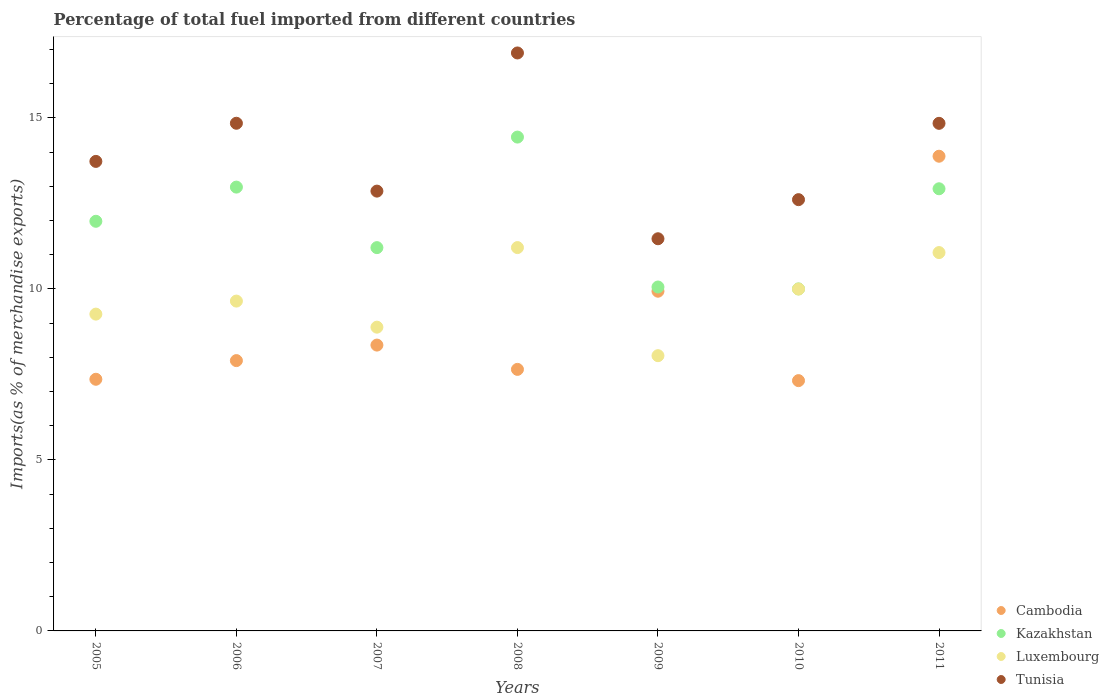Is the number of dotlines equal to the number of legend labels?
Provide a succinct answer. Yes. What is the percentage of imports to different countries in Kazakhstan in 2005?
Your answer should be compact. 11.98. Across all years, what is the maximum percentage of imports to different countries in Kazakhstan?
Offer a very short reply. 14.44. Across all years, what is the minimum percentage of imports to different countries in Cambodia?
Make the answer very short. 7.32. What is the total percentage of imports to different countries in Tunisia in the graph?
Your answer should be compact. 97.25. What is the difference between the percentage of imports to different countries in Cambodia in 2010 and that in 2011?
Provide a short and direct response. -6.56. What is the difference between the percentage of imports to different countries in Cambodia in 2011 and the percentage of imports to different countries in Luxembourg in 2010?
Offer a terse response. 3.88. What is the average percentage of imports to different countries in Luxembourg per year?
Ensure brevity in your answer.  9.73. In the year 2005, what is the difference between the percentage of imports to different countries in Luxembourg and percentage of imports to different countries in Kazakhstan?
Give a very brief answer. -2.71. In how many years, is the percentage of imports to different countries in Tunisia greater than 8 %?
Provide a succinct answer. 7. What is the ratio of the percentage of imports to different countries in Cambodia in 2006 to that in 2008?
Your response must be concise. 1.03. Is the percentage of imports to different countries in Cambodia in 2007 less than that in 2011?
Make the answer very short. Yes. What is the difference between the highest and the second highest percentage of imports to different countries in Kazakhstan?
Provide a short and direct response. 1.46. What is the difference between the highest and the lowest percentage of imports to different countries in Luxembourg?
Provide a succinct answer. 3.16. Is it the case that in every year, the sum of the percentage of imports to different countries in Kazakhstan and percentage of imports to different countries in Luxembourg  is greater than the sum of percentage of imports to different countries in Cambodia and percentage of imports to different countries in Tunisia?
Offer a very short reply. No. Is it the case that in every year, the sum of the percentage of imports to different countries in Tunisia and percentage of imports to different countries in Cambodia  is greater than the percentage of imports to different countries in Kazakhstan?
Keep it short and to the point. Yes. What is the difference between two consecutive major ticks on the Y-axis?
Give a very brief answer. 5. How are the legend labels stacked?
Provide a succinct answer. Vertical. What is the title of the graph?
Keep it short and to the point. Percentage of total fuel imported from different countries. What is the label or title of the Y-axis?
Keep it short and to the point. Imports(as % of merchandise exports). What is the Imports(as % of merchandise exports) of Cambodia in 2005?
Give a very brief answer. 7.36. What is the Imports(as % of merchandise exports) in Kazakhstan in 2005?
Ensure brevity in your answer.  11.98. What is the Imports(as % of merchandise exports) of Luxembourg in 2005?
Your answer should be very brief. 9.26. What is the Imports(as % of merchandise exports) in Tunisia in 2005?
Your response must be concise. 13.73. What is the Imports(as % of merchandise exports) in Cambodia in 2006?
Your answer should be compact. 7.9. What is the Imports(as % of merchandise exports) in Kazakhstan in 2006?
Keep it short and to the point. 12.98. What is the Imports(as % of merchandise exports) in Luxembourg in 2006?
Your answer should be very brief. 9.64. What is the Imports(as % of merchandise exports) in Tunisia in 2006?
Keep it short and to the point. 14.84. What is the Imports(as % of merchandise exports) in Cambodia in 2007?
Offer a terse response. 8.36. What is the Imports(as % of merchandise exports) of Kazakhstan in 2007?
Offer a very short reply. 11.21. What is the Imports(as % of merchandise exports) of Luxembourg in 2007?
Keep it short and to the point. 8.88. What is the Imports(as % of merchandise exports) of Tunisia in 2007?
Provide a succinct answer. 12.86. What is the Imports(as % of merchandise exports) in Cambodia in 2008?
Give a very brief answer. 7.65. What is the Imports(as % of merchandise exports) in Kazakhstan in 2008?
Provide a succinct answer. 14.44. What is the Imports(as % of merchandise exports) of Luxembourg in 2008?
Your answer should be very brief. 11.21. What is the Imports(as % of merchandise exports) in Tunisia in 2008?
Make the answer very short. 16.9. What is the Imports(as % of merchandise exports) of Cambodia in 2009?
Ensure brevity in your answer.  9.93. What is the Imports(as % of merchandise exports) in Kazakhstan in 2009?
Provide a short and direct response. 10.06. What is the Imports(as % of merchandise exports) of Luxembourg in 2009?
Give a very brief answer. 8.05. What is the Imports(as % of merchandise exports) in Tunisia in 2009?
Give a very brief answer. 11.47. What is the Imports(as % of merchandise exports) in Cambodia in 2010?
Make the answer very short. 7.32. What is the Imports(as % of merchandise exports) of Kazakhstan in 2010?
Offer a terse response. 10. What is the Imports(as % of merchandise exports) of Luxembourg in 2010?
Offer a terse response. 10. What is the Imports(as % of merchandise exports) in Tunisia in 2010?
Provide a short and direct response. 12.61. What is the Imports(as % of merchandise exports) in Cambodia in 2011?
Provide a succinct answer. 13.88. What is the Imports(as % of merchandise exports) of Kazakhstan in 2011?
Offer a terse response. 12.93. What is the Imports(as % of merchandise exports) in Luxembourg in 2011?
Offer a terse response. 11.06. What is the Imports(as % of merchandise exports) in Tunisia in 2011?
Ensure brevity in your answer.  14.84. Across all years, what is the maximum Imports(as % of merchandise exports) in Cambodia?
Make the answer very short. 13.88. Across all years, what is the maximum Imports(as % of merchandise exports) of Kazakhstan?
Your answer should be compact. 14.44. Across all years, what is the maximum Imports(as % of merchandise exports) of Luxembourg?
Offer a very short reply. 11.21. Across all years, what is the maximum Imports(as % of merchandise exports) of Tunisia?
Keep it short and to the point. 16.9. Across all years, what is the minimum Imports(as % of merchandise exports) in Cambodia?
Offer a terse response. 7.32. Across all years, what is the minimum Imports(as % of merchandise exports) in Kazakhstan?
Give a very brief answer. 10. Across all years, what is the minimum Imports(as % of merchandise exports) in Luxembourg?
Provide a short and direct response. 8.05. Across all years, what is the minimum Imports(as % of merchandise exports) in Tunisia?
Your answer should be compact. 11.47. What is the total Imports(as % of merchandise exports) in Cambodia in the graph?
Give a very brief answer. 62.4. What is the total Imports(as % of merchandise exports) of Kazakhstan in the graph?
Ensure brevity in your answer.  83.58. What is the total Imports(as % of merchandise exports) in Luxembourg in the graph?
Give a very brief answer. 68.1. What is the total Imports(as % of merchandise exports) of Tunisia in the graph?
Keep it short and to the point. 97.25. What is the difference between the Imports(as % of merchandise exports) of Cambodia in 2005 and that in 2006?
Make the answer very short. -0.55. What is the difference between the Imports(as % of merchandise exports) of Kazakhstan in 2005 and that in 2006?
Make the answer very short. -1. What is the difference between the Imports(as % of merchandise exports) of Luxembourg in 2005 and that in 2006?
Make the answer very short. -0.38. What is the difference between the Imports(as % of merchandise exports) in Tunisia in 2005 and that in 2006?
Offer a terse response. -1.12. What is the difference between the Imports(as % of merchandise exports) of Cambodia in 2005 and that in 2007?
Provide a short and direct response. -1. What is the difference between the Imports(as % of merchandise exports) in Kazakhstan in 2005 and that in 2007?
Provide a short and direct response. 0.77. What is the difference between the Imports(as % of merchandise exports) of Luxembourg in 2005 and that in 2007?
Your answer should be very brief. 0.38. What is the difference between the Imports(as % of merchandise exports) of Tunisia in 2005 and that in 2007?
Provide a succinct answer. 0.87. What is the difference between the Imports(as % of merchandise exports) in Cambodia in 2005 and that in 2008?
Give a very brief answer. -0.29. What is the difference between the Imports(as % of merchandise exports) in Kazakhstan in 2005 and that in 2008?
Your answer should be compact. -2.46. What is the difference between the Imports(as % of merchandise exports) of Luxembourg in 2005 and that in 2008?
Provide a succinct answer. -1.95. What is the difference between the Imports(as % of merchandise exports) of Tunisia in 2005 and that in 2008?
Ensure brevity in your answer.  -3.17. What is the difference between the Imports(as % of merchandise exports) in Cambodia in 2005 and that in 2009?
Provide a short and direct response. -2.57. What is the difference between the Imports(as % of merchandise exports) in Kazakhstan in 2005 and that in 2009?
Provide a succinct answer. 1.92. What is the difference between the Imports(as % of merchandise exports) in Luxembourg in 2005 and that in 2009?
Ensure brevity in your answer.  1.22. What is the difference between the Imports(as % of merchandise exports) in Tunisia in 2005 and that in 2009?
Offer a very short reply. 2.26. What is the difference between the Imports(as % of merchandise exports) of Cambodia in 2005 and that in 2010?
Offer a terse response. 0.04. What is the difference between the Imports(as % of merchandise exports) of Kazakhstan in 2005 and that in 2010?
Provide a short and direct response. 1.98. What is the difference between the Imports(as % of merchandise exports) of Luxembourg in 2005 and that in 2010?
Ensure brevity in your answer.  -0.73. What is the difference between the Imports(as % of merchandise exports) of Tunisia in 2005 and that in 2010?
Keep it short and to the point. 1.12. What is the difference between the Imports(as % of merchandise exports) in Cambodia in 2005 and that in 2011?
Ensure brevity in your answer.  -6.52. What is the difference between the Imports(as % of merchandise exports) in Kazakhstan in 2005 and that in 2011?
Provide a succinct answer. -0.95. What is the difference between the Imports(as % of merchandise exports) in Luxembourg in 2005 and that in 2011?
Offer a very short reply. -1.8. What is the difference between the Imports(as % of merchandise exports) in Tunisia in 2005 and that in 2011?
Give a very brief answer. -1.11. What is the difference between the Imports(as % of merchandise exports) in Cambodia in 2006 and that in 2007?
Your response must be concise. -0.45. What is the difference between the Imports(as % of merchandise exports) of Kazakhstan in 2006 and that in 2007?
Provide a succinct answer. 1.77. What is the difference between the Imports(as % of merchandise exports) in Luxembourg in 2006 and that in 2007?
Provide a short and direct response. 0.76. What is the difference between the Imports(as % of merchandise exports) of Tunisia in 2006 and that in 2007?
Your response must be concise. 1.98. What is the difference between the Imports(as % of merchandise exports) of Cambodia in 2006 and that in 2008?
Keep it short and to the point. 0.26. What is the difference between the Imports(as % of merchandise exports) of Kazakhstan in 2006 and that in 2008?
Your response must be concise. -1.46. What is the difference between the Imports(as % of merchandise exports) in Luxembourg in 2006 and that in 2008?
Offer a terse response. -1.56. What is the difference between the Imports(as % of merchandise exports) of Tunisia in 2006 and that in 2008?
Provide a short and direct response. -2.06. What is the difference between the Imports(as % of merchandise exports) in Cambodia in 2006 and that in 2009?
Make the answer very short. -2.03. What is the difference between the Imports(as % of merchandise exports) in Kazakhstan in 2006 and that in 2009?
Offer a very short reply. 2.92. What is the difference between the Imports(as % of merchandise exports) in Luxembourg in 2006 and that in 2009?
Give a very brief answer. 1.6. What is the difference between the Imports(as % of merchandise exports) of Tunisia in 2006 and that in 2009?
Keep it short and to the point. 3.38. What is the difference between the Imports(as % of merchandise exports) in Cambodia in 2006 and that in 2010?
Keep it short and to the point. 0.59. What is the difference between the Imports(as % of merchandise exports) of Kazakhstan in 2006 and that in 2010?
Provide a short and direct response. 2.98. What is the difference between the Imports(as % of merchandise exports) of Luxembourg in 2006 and that in 2010?
Keep it short and to the point. -0.35. What is the difference between the Imports(as % of merchandise exports) in Tunisia in 2006 and that in 2010?
Provide a short and direct response. 2.23. What is the difference between the Imports(as % of merchandise exports) in Cambodia in 2006 and that in 2011?
Make the answer very short. -5.98. What is the difference between the Imports(as % of merchandise exports) of Kazakhstan in 2006 and that in 2011?
Provide a short and direct response. 0.05. What is the difference between the Imports(as % of merchandise exports) of Luxembourg in 2006 and that in 2011?
Keep it short and to the point. -1.42. What is the difference between the Imports(as % of merchandise exports) of Tunisia in 2006 and that in 2011?
Offer a terse response. 0. What is the difference between the Imports(as % of merchandise exports) of Cambodia in 2007 and that in 2008?
Keep it short and to the point. 0.71. What is the difference between the Imports(as % of merchandise exports) in Kazakhstan in 2007 and that in 2008?
Your response must be concise. -3.23. What is the difference between the Imports(as % of merchandise exports) of Luxembourg in 2007 and that in 2008?
Provide a short and direct response. -2.33. What is the difference between the Imports(as % of merchandise exports) of Tunisia in 2007 and that in 2008?
Offer a very short reply. -4.04. What is the difference between the Imports(as % of merchandise exports) of Cambodia in 2007 and that in 2009?
Offer a terse response. -1.57. What is the difference between the Imports(as % of merchandise exports) of Kazakhstan in 2007 and that in 2009?
Give a very brief answer. 1.15. What is the difference between the Imports(as % of merchandise exports) in Luxembourg in 2007 and that in 2009?
Provide a succinct answer. 0.83. What is the difference between the Imports(as % of merchandise exports) of Tunisia in 2007 and that in 2009?
Give a very brief answer. 1.39. What is the difference between the Imports(as % of merchandise exports) in Cambodia in 2007 and that in 2010?
Make the answer very short. 1.04. What is the difference between the Imports(as % of merchandise exports) in Kazakhstan in 2007 and that in 2010?
Your answer should be compact. 1.21. What is the difference between the Imports(as % of merchandise exports) in Luxembourg in 2007 and that in 2010?
Offer a terse response. -1.11. What is the difference between the Imports(as % of merchandise exports) in Tunisia in 2007 and that in 2010?
Offer a very short reply. 0.25. What is the difference between the Imports(as % of merchandise exports) of Cambodia in 2007 and that in 2011?
Offer a very short reply. -5.52. What is the difference between the Imports(as % of merchandise exports) in Kazakhstan in 2007 and that in 2011?
Your answer should be very brief. -1.72. What is the difference between the Imports(as % of merchandise exports) of Luxembourg in 2007 and that in 2011?
Your answer should be very brief. -2.18. What is the difference between the Imports(as % of merchandise exports) in Tunisia in 2007 and that in 2011?
Your answer should be very brief. -1.98. What is the difference between the Imports(as % of merchandise exports) in Cambodia in 2008 and that in 2009?
Provide a short and direct response. -2.29. What is the difference between the Imports(as % of merchandise exports) of Kazakhstan in 2008 and that in 2009?
Offer a very short reply. 4.38. What is the difference between the Imports(as % of merchandise exports) in Luxembourg in 2008 and that in 2009?
Make the answer very short. 3.16. What is the difference between the Imports(as % of merchandise exports) in Tunisia in 2008 and that in 2009?
Keep it short and to the point. 5.43. What is the difference between the Imports(as % of merchandise exports) in Cambodia in 2008 and that in 2010?
Ensure brevity in your answer.  0.33. What is the difference between the Imports(as % of merchandise exports) in Kazakhstan in 2008 and that in 2010?
Keep it short and to the point. 4.44. What is the difference between the Imports(as % of merchandise exports) of Luxembourg in 2008 and that in 2010?
Make the answer very short. 1.21. What is the difference between the Imports(as % of merchandise exports) in Tunisia in 2008 and that in 2010?
Provide a succinct answer. 4.29. What is the difference between the Imports(as % of merchandise exports) in Cambodia in 2008 and that in 2011?
Offer a terse response. -6.23. What is the difference between the Imports(as % of merchandise exports) of Kazakhstan in 2008 and that in 2011?
Your answer should be very brief. 1.51. What is the difference between the Imports(as % of merchandise exports) of Luxembourg in 2008 and that in 2011?
Your answer should be very brief. 0.15. What is the difference between the Imports(as % of merchandise exports) in Tunisia in 2008 and that in 2011?
Give a very brief answer. 2.06. What is the difference between the Imports(as % of merchandise exports) in Cambodia in 2009 and that in 2010?
Your response must be concise. 2.61. What is the difference between the Imports(as % of merchandise exports) of Kazakhstan in 2009 and that in 2010?
Ensure brevity in your answer.  0.06. What is the difference between the Imports(as % of merchandise exports) of Luxembourg in 2009 and that in 2010?
Make the answer very short. -1.95. What is the difference between the Imports(as % of merchandise exports) in Tunisia in 2009 and that in 2010?
Your answer should be very brief. -1.14. What is the difference between the Imports(as % of merchandise exports) of Cambodia in 2009 and that in 2011?
Give a very brief answer. -3.95. What is the difference between the Imports(as % of merchandise exports) in Kazakhstan in 2009 and that in 2011?
Give a very brief answer. -2.87. What is the difference between the Imports(as % of merchandise exports) of Luxembourg in 2009 and that in 2011?
Offer a very short reply. -3.01. What is the difference between the Imports(as % of merchandise exports) in Tunisia in 2009 and that in 2011?
Your answer should be compact. -3.37. What is the difference between the Imports(as % of merchandise exports) of Cambodia in 2010 and that in 2011?
Your answer should be very brief. -6.56. What is the difference between the Imports(as % of merchandise exports) of Kazakhstan in 2010 and that in 2011?
Your answer should be compact. -2.93. What is the difference between the Imports(as % of merchandise exports) in Luxembourg in 2010 and that in 2011?
Keep it short and to the point. -1.07. What is the difference between the Imports(as % of merchandise exports) in Tunisia in 2010 and that in 2011?
Your answer should be compact. -2.23. What is the difference between the Imports(as % of merchandise exports) of Cambodia in 2005 and the Imports(as % of merchandise exports) of Kazakhstan in 2006?
Keep it short and to the point. -5.62. What is the difference between the Imports(as % of merchandise exports) in Cambodia in 2005 and the Imports(as % of merchandise exports) in Luxembourg in 2006?
Provide a succinct answer. -2.29. What is the difference between the Imports(as % of merchandise exports) of Cambodia in 2005 and the Imports(as % of merchandise exports) of Tunisia in 2006?
Your response must be concise. -7.49. What is the difference between the Imports(as % of merchandise exports) of Kazakhstan in 2005 and the Imports(as % of merchandise exports) of Luxembourg in 2006?
Your answer should be compact. 2.33. What is the difference between the Imports(as % of merchandise exports) in Kazakhstan in 2005 and the Imports(as % of merchandise exports) in Tunisia in 2006?
Offer a very short reply. -2.87. What is the difference between the Imports(as % of merchandise exports) in Luxembourg in 2005 and the Imports(as % of merchandise exports) in Tunisia in 2006?
Keep it short and to the point. -5.58. What is the difference between the Imports(as % of merchandise exports) of Cambodia in 2005 and the Imports(as % of merchandise exports) of Kazakhstan in 2007?
Your answer should be compact. -3.85. What is the difference between the Imports(as % of merchandise exports) of Cambodia in 2005 and the Imports(as % of merchandise exports) of Luxembourg in 2007?
Provide a succinct answer. -1.52. What is the difference between the Imports(as % of merchandise exports) in Cambodia in 2005 and the Imports(as % of merchandise exports) in Tunisia in 2007?
Your answer should be very brief. -5.5. What is the difference between the Imports(as % of merchandise exports) of Kazakhstan in 2005 and the Imports(as % of merchandise exports) of Luxembourg in 2007?
Ensure brevity in your answer.  3.1. What is the difference between the Imports(as % of merchandise exports) in Kazakhstan in 2005 and the Imports(as % of merchandise exports) in Tunisia in 2007?
Make the answer very short. -0.88. What is the difference between the Imports(as % of merchandise exports) in Luxembourg in 2005 and the Imports(as % of merchandise exports) in Tunisia in 2007?
Ensure brevity in your answer.  -3.6. What is the difference between the Imports(as % of merchandise exports) of Cambodia in 2005 and the Imports(as % of merchandise exports) of Kazakhstan in 2008?
Ensure brevity in your answer.  -7.08. What is the difference between the Imports(as % of merchandise exports) of Cambodia in 2005 and the Imports(as % of merchandise exports) of Luxembourg in 2008?
Keep it short and to the point. -3.85. What is the difference between the Imports(as % of merchandise exports) in Cambodia in 2005 and the Imports(as % of merchandise exports) in Tunisia in 2008?
Ensure brevity in your answer.  -9.54. What is the difference between the Imports(as % of merchandise exports) in Kazakhstan in 2005 and the Imports(as % of merchandise exports) in Luxembourg in 2008?
Ensure brevity in your answer.  0.77. What is the difference between the Imports(as % of merchandise exports) of Kazakhstan in 2005 and the Imports(as % of merchandise exports) of Tunisia in 2008?
Offer a terse response. -4.92. What is the difference between the Imports(as % of merchandise exports) of Luxembourg in 2005 and the Imports(as % of merchandise exports) of Tunisia in 2008?
Make the answer very short. -7.64. What is the difference between the Imports(as % of merchandise exports) in Cambodia in 2005 and the Imports(as % of merchandise exports) in Kazakhstan in 2009?
Keep it short and to the point. -2.7. What is the difference between the Imports(as % of merchandise exports) in Cambodia in 2005 and the Imports(as % of merchandise exports) in Luxembourg in 2009?
Keep it short and to the point. -0.69. What is the difference between the Imports(as % of merchandise exports) in Cambodia in 2005 and the Imports(as % of merchandise exports) in Tunisia in 2009?
Provide a short and direct response. -4.11. What is the difference between the Imports(as % of merchandise exports) of Kazakhstan in 2005 and the Imports(as % of merchandise exports) of Luxembourg in 2009?
Provide a succinct answer. 3.93. What is the difference between the Imports(as % of merchandise exports) in Kazakhstan in 2005 and the Imports(as % of merchandise exports) in Tunisia in 2009?
Your answer should be very brief. 0.51. What is the difference between the Imports(as % of merchandise exports) in Luxembourg in 2005 and the Imports(as % of merchandise exports) in Tunisia in 2009?
Give a very brief answer. -2.2. What is the difference between the Imports(as % of merchandise exports) in Cambodia in 2005 and the Imports(as % of merchandise exports) in Kazakhstan in 2010?
Your answer should be very brief. -2.64. What is the difference between the Imports(as % of merchandise exports) in Cambodia in 2005 and the Imports(as % of merchandise exports) in Luxembourg in 2010?
Offer a very short reply. -2.64. What is the difference between the Imports(as % of merchandise exports) in Cambodia in 2005 and the Imports(as % of merchandise exports) in Tunisia in 2010?
Give a very brief answer. -5.25. What is the difference between the Imports(as % of merchandise exports) in Kazakhstan in 2005 and the Imports(as % of merchandise exports) in Luxembourg in 2010?
Make the answer very short. 1.98. What is the difference between the Imports(as % of merchandise exports) in Kazakhstan in 2005 and the Imports(as % of merchandise exports) in Tunisia in 2010?
Provide a short and direct response. -0.63. What is the difference between the Imports(as % of merchandise exports) of Luxembourg in 2005 and the Imports(as % of merchandise exports) of Tunisia in 2010?
Make the answer very short. -3.35. What is the difference between the Imports(as % of merchandise exports) of Cambodia in 2005 and the Imports(as % of merchandise exports) of Kazakhstan in 2011?
Offer a terse response. -5.57. What is the difference between the Imports(as % of merchandise exports) of Cambodia in 2005 and the Imports(as % of merchandise exports) of Luxembourg in 2011?
Give a very brief answer. -3.7. What is the difference between the Imports(as % of merchandise exports) in Cambodia in 2005 and the Imports(as % of merchandise exports) in Tunisia in 2011?
Your response must be concise. -7.48. What is the difference between the Imports(as % of merchandise exports) in Kazakhstan in 2005 and the Imports(as % of merchandise exports) in Luxembourg in 2011?
Offer a terse response. 0.91. What is the difference between the Imports(as % of merchandise exports) of Kazakhstan in 2005 and the Imports(as % of merchandise exports) of Tunisia in 2011?
Provide a succinct answer. -2.86. What is the difference between the Imports(as % of merchandise exports) of Luxembourg in 2005 and the Imports(as % of merchandise exports) of Tunisia in 2011?
Your response must be concise. -5.58. What is the difference between the Imports(as % of merchandise exports) in Cambodia in 2006 and the Imports(as % of merchandise exports) in Kazakhstan in 2007?
Offer a terse response. -3.3. What is the difference between the Imports(as % of merchandise exports) in Cambodia in 2006 and the Imports(as % of merchandise exports) in Luxembourg in 2007?
Provide a short and direct response. -0.98. What is the difference between the Imports(as % of merchandise exports) of Cambodia in 2006 and the Imports(as % of merchandise exports) of Tunisia in 2007?
Offer a very short reply. -4.96. What is the difference between the Imports(as % of merchandise exports) of Kazakhstan in 2006 and the Imports(as % of merchandise exports) of Luxembourg in 2007?
Ensure brevity in your answer.  4.1. What is the difference between the Imports(as % of merchandise exports) in Kazakhstan in 2006 and the Imports(as % of merchandise exports) in Tunisia in 2007?
Your answer should be very brief. 0.12. What is the difference between the Imports(as % of merchandise exports) in Luxembourg in 2006 and the Imports(as % of merchandise exports) in Tunisia in 2007?
Offer a very short reply. -3.22. What is the difference between the Imports(as % of merchandise exports) of Cambodia in 2006 and the Imports(as % of merchandise exports) of Kazakhstan in 2008?
Provide a short and direct response. -6.54. What is the difference between the Imports(as % of merchandise exports) of Cambodia in 2006 and the Imports(as % of merchandise exports) of Luxembourg in 2008?
Make the answer very short. -3.3. What is the difference between the Imports(as % of merchandise exports) in Cambodia in 2006 and the Imports(as % of merchandise exports) in Tunisia in 2008?
Your answer should be very brief. -9. What is the difference between the Imports(as % of merchandise exports) in Kazakhstan in 2006 and the Imports(as % of merchandise exports) in Luxembourg in 2008?
Make the answer very short. 1.77. What is the difference between the Imports(as % of merchandise exports) in Kazakhstan in 2006 and the Imports(as % of merchandise exports) in Tunisia in 2008?
Provide a succinct answer. -3.92. What is the difference between the Imports(as % of merchandise exports) of Luxembourg in 2006 and the Imports(as % of merchandise exports) of Tunisia in 2008?
Make the answer very short. -7.25. What is the difference between the Imports(as % of merchandise exports) in Cambodia in 2006 and the Imports(as % of merchandise exports) in Kazakhstan in 2009?
Offer a very short reply. -2.15. What is the difference between the Imports(as % of merchandise exports) in Cambodia in 2006 and the Imports(as % of merchandise exports) in Luxembourg in 2009?
Your answer should be compact. -0.14. What is the difference between the Imports(as % of merchandise exports) in Cambodia in 2006 and the Imports(as % of merchandise exports) in Tunisia in 2009?
Your response must be concise. -3.56. What is the difference between the Imports(as % of merchandise exports) in Kazakhstan in 2006 and the Imports(as % of merchandise exports) in Luxembourg in 2009?
Ensure brevity in your answer.  4.93. What is the difference between the Imports(as % of merchandise exports) in Kazakhstan in 2006 and the Imports(as % of merchandise exports) in Tunisia in 2009?
Make the answer very short. 1.51. What is the difference between the Imports(as % of merchandise exports) of Luxembourg in 2006 and the Imports(as % of merchandise exports) of Tunisia in 2009?
Offer a very short reply. -1.82. What is the difference between the Imports(as % of merchandise exports) in Cambodia in 2006 and the Imports(as % of merchandise exports) in Kazakhstan in 2010?
Make the answer very short. -2.1. What is the difference between the Imports(as % of merchandise exports) in Cambodia in 2006 and the Imports(as % of merchandise exports) in Luxembourg in 2010?
Provide a short and direct response. -2.09. What is the difference between the Imports(as % of merchandise exports) in Cambodia in 2006 and the Imports(as % of merchandise exports) in Tunisia in 2010?
Keep it short and to the point. -4.71. What is the difference between the Imports(as % of merchandise exports) of Kazakhstan in 2006 and the Imports(as % of merchandise exports) of Luxembourg in 2010?
Ensure brevity in your answer.  2.98. What is the difference between the Imports(as % of merchandise exports) of Kazakhstan in 2006 and the Imports(as % of merchandise exports) of Tunisia in 2010?
Your answer should be compact. 0.37. What is the difference between the Imports(as % of merchandise exports) in Luxembourg in 2006 and the Imports(as % of merchandise exports) in Tunisia in 2010?
Offer a terse response. -2.97. What is the difference between the Imports(as % of merchandise exports) of Cambodia in 2006 and the Imports(as % of merchandise exports) of Kazakhstan in 2011?
Keep it short and to the point. -5.02. What is the difference between the Imports(as % of merchandise exports) in Cambodia in 2006 and the Imports(as % of merchandise exports) in Luxembourg in 2011?
Keep it short and to the point. -3.16. What is the difference between the Imports(as % of merchandise exports) in Cambodia in 2006 and the Imports(as % of merchandise exports) in Tunisia in 2011?
Keep it short and to the point. -6.94. What is the difference between the Imports(as % of merchandise exports) of Kazakhstan in 2006 and the Imports(as % of merchandise exports) of Luxembourg in 2011?
Offer a very short reply. 1.91. What is the difference between the Imports(as % of merchandise exports) in Kazakhstan in 2006 and the Imports(as % of merchandise exports) in Tunisia in 2011?
Offer a terse response. -1.86. What is the difference between the Imports(as % of merchandise exports) of Luxembourg in 2006 and the Imports(as % of merchandise exports) of Tunisia in 2011?
Offer a very short reply. -5.2. What is the difference between the Imports(as % of merchandise exports) of Cambodia in 2007 and the Imports(as % of merchandise exports) of Kazakhstan in 2008?
Provide a succinct answer. -6.08. What is the difference between the Imports(as % of merchandise exports) of Cambodia in 2007 and the Imports(as % of merchandise exports) of Luxembourg in 2008?
Your answer should be very brief. -2.85. What is the difference between the Imports(as % of merchandise exports) in Cambodia in 2007 and the Imports(as % of merchandise exports) in Tunisia in 2008?
Ensure brevity in your answer.  -8.54. What is the difference between the Imports(as % of merchandise exports) of Kazakhstan in 2007 and the Imports(as % of merchandise exports) of Luxembourg in 2008?
Offer a very short reply. -0. What is the difference between the Imports(as % of merchandise exports) in Kazakhstan in 2007 and the Imports(as % of merchandise exports) in Tunisia in 2008?
Make the answer very short. -5.69. What is the difference between the Imports(as % of merchandise exports) of Luxembourg in 2007 and the Imports(as % of merchandise exports) of Tunisia in 2008?
Your answer should be compact. -8.02. What is the difference between the Imports(as % of merchandise exports) in Cambodia in 2007 and the Imports(as % of merchandise exports) in Kazakhstan in 2009?
Make the answer very short. -1.7. What is the difference between the Imports(as % of merchandise exports) in Cambodia in 2007 and the Imports(as % of merchandise exports) in Luxembourg in 2009?
Give a very brief answer. 0.31. What is the difference between the Imports(as % of merchandise exports) in Cambodia in 2007 and the Imports(as % of merchandise exports) in Tunisia in 2009?
Offer a terse response. -3.11. What is the difference between the Imports(as % of merchandise exports) of Kazakhstan in 2007 and the Imports(as % of merchandise exports) of Luxembourg in 2009?
Ensure brevity in your answer.  3.16. What is the difference between the Imports(as % of merchandise exports) of Kazakhstan in 2007 and the Imports(as % of merchandise exports) of Tunisia in 2009?
Ensure brevity in your answer.  -0.26. What is the difference between the Imports(as % of merchandise exports) in Luxembourg in 2007 and the Imports(as % of merchandise exports) in Tunisia in 2009?
Your response must be concise. -2.59. What is the difference between the Imports(as % of merchandise exports) in Cambodia in 2007 and the Imports(as % of merchandise exports) in Kazakhstan in 2010?
Give a very brief answer. -1.64. What is the difference between the Imports(as % of merchandise exports) in Cambodia in 2007 and the Imports(as % of merchandise exports) in Luxembourg in 2010?
Your answer should be very brief. -1.64. What is the difference between the Imports(as % of merchandise exports) in Cambodia in 2007 and the Imports(as % of merchandise exports) in Tunisia in 2010?
Your response must be concise. -4.25. What is the difference between the Imports(as % of merchandise exports) in Kazakhstan in 2007 and the Imports(as % of merchandise exports) in Luxembourg in 2010?
Your answer should be compact. 1.21. What is the difference between the Imports(as % of merchandise exports) of Kazakhstan in 2007 and the Imports(as % of merchandise exports) of Tunisia in 2010?
Offer a terse response. -1.4. What is the difference between the Imports(as % of merchandise exports) in Luxembourg in 2007 and the Imports(as % of merchandise exports) in Tunisia in 2010?
Your answer should be compact. -3.73. What is the difference between the Imports(as % of merchandise exports) of Cambodia in 2007 and the Imports(as % of merchandise exports) of Kazakhstan in 2011?
Provide a short and direct response. -4.57. What is the difference between the Imports(as % of merchandise exports) in Cambodia in 2007 and the Imports(as % of merchandise exports) in Luxembourg in 2011?
Provide a short and direct response. -2.71. What is the difference between the Imports(as % of merchandise exports) in Cambodia in 2007 and the Imports(as % of merchandise exports) in Tunisia in 2011?
Keep it short and to the point. -6.48. What is the difference between the Imports(as % of merchandise exports) in Kazakhstan in 2007 and the Imports(as % of merchandise exports) in Luxembourg in 2011?
Ensure brevity in your answer.  0.14. What is the difference between the Imports(as % of merchandise exports) of Kazakhstan in 2007 and the Imports(as % of merchandise exports) of Tunisia in 2011?
Provide a short and direct response. -3.63. What is the difference between the Imports(as % of merchandise exports) of Luxembourg in 2007 and the Imports(as % of merchandise exports) of Tunisia in 2011?
Your response must be concise. -5.96. What is the difference between the Imports(as % of merchandise exports) in Cambodia in 2008 and the Imports(as % of merchandise exports) in Kazakhstan in 2009?
Make the answer very short. -2.41. What is the difference between the Imports(as % of merchandise exports) of Cambodia in 2008 and the Imports(as % of merchandise exports) of Luxembourg in 2009?
Provide a succinct answer. -0.4. What is the difference between the Imports(as % of merchandise exports) in Cambodia in 2008 and the Imports(as % of merchandise exports) in Tunisia in 2009?
Offer a very short reply. -3.82. What is the difference between the Imports(as % of merchandise exports) of Kazakhstan in 2008 and the Imports(as % of merchandise exports) of Luxembourg in 2009?
Offer a terse response. 6.39. What is the difference between the Imports(as % of merchandise exports) in Kazakhstan in 2008 and the Imports(as % of merchandise exports) in Tunisia in 2009?
Your answer should be very brief. 2.97. What is the difference between the Imports(as % of merchandise exports) in Luxembourg in 2008 and the Imports(as % of merchandise exports) in Tunisia in 2009?
Give a very brief answer. -0.26. What is the difference between the Imports(as % of merchandise exports) of Cambodia in 2008 and the Imports(as % of merchandise exports) of Kazakhstan in 2010?
Keep it short and to the point. -2.35. What is the difference between the Imports(as % of merchandise exports) in Cambodia in 2008 and the Imports(as % of merchandise exports) in Luxembourg in 2010?
Your answer should be compact. -2.35. What is the difference between the Imports(as % of merchandise exports) of Cambodia in 2008 and the Imports(as % of merchandise exports) of Tunisia in 2010?
Offer a very short reply. -4.96. What is the difference between the Imports(as % of merchandise exports) in Kazakhstan in 2008 and the Imports(as % of merchandise exports) in Luxembourg in 2010?
Provide a succinct answer. 4.44. What is the difference between the Imports(as % of merchandise exports) in Kazakhstan in 2008 and the Imports(as % of merchandise exports) in Tunisia in 2010?
Provide a succinct answer. 1.83. What is the difference between the Imports(as % of merchandise exports) of Luxembourg in 2008 and the Imports(as % of merchandise exports) of Tunisia in 2010?
Ensure brevity in your answer.  -1.4. What is the difference between the Imports(as % of merchandise exports) of Cambodia in 2008 and the Imports(as % of merchandise exports) of Kazakhstan in 2011?
Make the answer very short. -5.28. What is the difference between the Imports(as % of merchandise exports) in Cambodia in 2008 and the Imports(as % of merchandise exports) in Luxembourg in 2011?
Provide a short and direct response. -3.42. What is the difference between the Imports(as % of merchandise exports) of Cambodia in 2008 and the Imports(as % of merchandise exports) of Tunisia in 2011?
Provide a short and direct response. -7.19. What is the difference between the Imports(as % of merchandise exports) in Kazakhstan in 2008 and the Imports(as % of merchandise exports) in Luxembourg in 2011?
Ensure brevity in your answer.  3.38. What is the difference between the Imports(as % of merchandise exports) of Kazakhstan in 2008 and the Imports(as % of merchandise exports) of Tunisia in 2011?
Give a very brief answer. -0.4. What is the difference between the Imports(as % of merchandise exports) in Luxembourg in 2008 and the Imports(as % of merchandise exports) in Tunisia in 2011?
Provide a short and direct response. -3.63. What is the difference between the Imports(as % of merchandise exports) of Cambodia in 2009 and the Imports(as % of merchandise exports) of Kazakhstan in 2010?
Ensure brevity in your answer.  -0.07. What is the difference between the Imports(as % of merchandise exports) of Cambodia in 2009 and the Imports(as % of merchandise exports) of Luxembourg in 2010?
Provide a short and direct response. -0.06. What is the difference between the Imports(as % of merchandise exports) of Cambodia in 2009 and the Imports(as % of merchandise exports) of Tunisia in 2010?
Your answer should be compact. -2.68. What is the difference between the Imports(as % of merchandise exports) of Kazakhstan in 2009 and the Imports(as % of merchandise exports) of Luxembourg in 2010?
Your answer should be compact. 0.06. What is the difference between the Imports(as % of merchandise exports) in Kazakhstan in 2009 and the Imports(as % of merchandise exports) in Tunisia in 2010?
Give a very brief answer. -2.55. What is the difference between the Imports(as % of merchandise exports) of Luxembourg in 2009 and the Imports(as % of merchandise exports) of Tunisia in 2010?
Your response must be concise. -4.56. What is the difference between the Imports(as % of merchandise exports) of Cambodia in 2009 and the Imports(as % of merchandise exports) of Kazakhstan in 2011?
Ensure brevity in your answer.  -3. What is the difference between the Imports(as % of merchandise exports) of Cambodia in 2009 and the Imports(as % of merchandise exports) of Luxembourg in 2011?
Provide a short and direct response. -1.13. What is the difference between the Imports(as % of merchandise exports) of Cambodia in 2009 and the Imports(as % of merchandise exports) of Tunisia in 2011?
Provide a succinct answer. -4.91. What is the difference between the Imports(as % of merchandise exports) in Kazakhstan in 2009 and the Imports(as % of merchandise exports) in Luxembourg in 2011?
Make the answer very short. -1.01. What is the difference between the Imports(as % of merchandise exports) in Kazakhstan in 2009 and the Imports(as % of merchandise exports) in Tunisia in 2011?
Offer a very short reply. -4.79. What is the difference between the Imports(as % of merchandise exports) in Luxembourg in 2009 and the Imports(as % of merchandise exports) in Tunisia in 2011?
Provide a short and direct response. -6.79. What is the difference between the Imports(as % of merchandise exports) of Cambodia in 2010 and the Imports(as % of merchandise exports) of Kazakhstan in 2011?
Keep it short and to the point. -5.61. What is the difference between the Imports(as % of merchandise exports) of Cambodia in 2010 and the Imports(as % of merchandise exports) of Luxembourg in 2011?
Your response must be concise. -3.74. What is the difference between the Imports(as % of merchandise exports) of Cambodia in 2010 and the Imports(as % of merchandise exports) of Tunisia in 2011?
Offer a terse response. -7.52. What is the difference between the Imports(as % of merchandise exports) in Kazakhstan in 2010 and the Imports(as % of merchandise exports) in Luxembourg in 2011?
Make the answer very short. -1.06. What is the difference between the Imports(as % of merchandise exports) of Kazakhstan in 2010 and the Imports(as % of merchandise exports) of Tunisia in 2011?
Make the answer very short. -4.84. What is the difference between the Imports(as % of merchandise exports) in Luxembourg in 2010 and the Imports(as % of merchandise exports) in Tunisia in 2011?
Offer a very short reply. -4.85. What is the average Imports(as % of merchandise exports) of Cambodia per year?
Make the answer very short. 8.91. What is the average Imports(as % of merchandise exports) in Kazakhstan per year?
Your answer should be very brief. 11.94. What is the average Imports(as % of merchandise exports) in Luxembourg per year?
Give a very brief answer. 9.73. What is the average Imports(as % of merchandise exports) of Tunisia per year?
Provide a succinct answer. 13.89. In the year 2005, what is the difference between the Imports(as % of merchandise exports) of Cambodia and Imports(as % of merchandise exports) of Kazakhstan?
Provide a short and direct response. -4.62. In the year 2005, what is the difference between the Imports(as % of merchandise exports) of Cambodia and Imports(as % of merchandise exports) of Luxembourg?
Your answer should be compact. -1.9. In the year 2005, what is the difference between the Imports(as % of merchandise exports) in Cambodia and Imports(as % of merchandise exports) in Tunisia?
Provide a short and direct response. -6.37. In the year 2005, what is the difference between the Imports(as % of merchandise exports) of Kazakhstan and Imports(as % of merchandise exports) of Luxembourg?
Your response must be concise. 2.71. In the year 2005, what is the difference between the Imports(as % of merchandise exports) of Kazakhstan and Imports(as % of merchandise exports) of Tunisia?
Your answer should be compact. -1.75. In the year 2005, what is the difference between the Imports(as % of merchandise exports) in Luxembourg and Imports(as % of merchandise exports) in Tunisia?
Ensure brevity in your answer.  -4.47. In the year 2006, what is the difference between the Imports(as % of merchandise exports) in Cambodia and Imports(as % of merchandise exports) in Kazakhstan?
Your answer should be very brief. -5.07. In the year 2006, what is the difference between the Imports(as % of merchandise exports) in Cambodia and Imports(as % of merchandise exports) in Luxembourg?
Keep it short and to the point. -1.74. In the year 2006, what is the difference between the Imports(as % of merchandise exports) in Cambodia and Imports(as % of merchandise exports) in Tunisia?
Your answer should be very brief. -6.94. In the year 2006, what is the difference between the Imports(as % of merchandise exports) in Kazakhstan and Imports(as % of merchandise exports) in Luxembourg?
Provide a succinct answer. 3.33. In the year 2006, what is the difference between the Imports(as % of merchandise exports) in Kazakhstan and Imports(as % of merchandise exports) in Tunisia?
Ensure brevity in your answer.  -1.87. In the year 2006, what is the difference between the Imports(as % of merchandise exports) in Luxembourg and Imports(as % of merchandise exports) in Tunisia?
Offer a very short reply. -5.2. In the year 2007, what is the difference between the Imports(as % of merchandise exports) in Cambodia and Imports(as % of merchandise exports) in Kazakhstan?
Keep it short and to the point. -2.85. In the year 2007, what is the difference between the Imports(as % of merchandise exports) of Cambodia and Imports(as % of merchandise exports) of Luxembourg?
Provide a succinct answer. -0.52. In the year 2007, what is the difference between the Imports(as % of merchandise exports) in Cambodia and Imports(as % of merchandise exports) in Tunisia?
Ensure brevity in your answer.  -4.5. In the year 2007, what is the difference between the Imports(as % of merchandise exports) in Kazakhstan and Imports(as % of merchandise exports) in Luxembourg?
Your answer should be compact. 2.33. In the year 2007, what is the difference between the Imports(as % of merchandise exports) of Kazakhstan and Imports(as % of merchandise exports) of Tunisia?
Your answer should be compact. -1.65. In the year 2007, what is the difference between the Imports(as % of merchandise exports) of Luxembourg and Imports(as % of merchandise exports) of Tunisia?
Your answer should be compact. -3.98. In the year 2008, what is the difference between the Imports(as % of merchandise exports) in Cambodia and Imports(as % of merchandise exports) in Kazakhstan?
Make the answer very short. -6.79. In the year 2008, what is the difference between the Imports(as % of merchandise exports) in Cambodia and Imports(as % of merchandise exports) in Luxembourg?
Provide a short and direct response. -3.56. In the year 2008, what is the difference between the Imports(as % of merchandise exports) of Cambodia and Imports(as % of merchandise exports) of Tunisia?
Keep it short and to the point. -9.25. In the year 2008, what is the difference between the Imports(as % of merchandise exports) of Kazakhstan and Imports(as % of merchandise exports) of Luxembourg?
Your answer should be very brief. 3.23. In the year 2008, what is the difference between the Imports(as % of merchandise exports) in Kazakhstan and Imports(as % of merchandise exports) in Tunisia?
Offer a very short reply. -2.46. In the year 2008, what is the difference between the Imports(as % of merchandise exports) of Luxembourg and Imports(as % of merchandise exports) of Tunisia?
Offer a terse response. -5.69. In the year 2009, what is the difference between the Imports(as % of merchandise exports) in Cambodia and Imports(as % of merchandise exports) in Kazakhstan?
Your answer should be very brief. -0.12. In the year 2009, what is the difference between the Imports(as % of merchandise exports) of Cambodia and Imports(as % of merchandise exports) of Luxembourg?
Offer a terse response. 1.88. In the year 2009, what is the difference between the Imports(as % of merchandise exports) in Cambodia and Imports(as % of merchandise exports) in Tunisia?
Your answer should be compact. -1.53. In the year 2009, what is the difference between the Imports(as % of merchandise exports) of Kazakhstan and Imports(as % of merchandise exports) of Luxembourg?
Ensure brevity in your answer.  2.01. In the year 2009, what is the difference between the Imports(as % of merchandise exports) of Kazakhstan and Imports(as % of merchandise exports) of Tunisia?
Keep it short and to the point. -1.41. In the year 2009, what is the difference between the Imports(as % of merchandise exports) in Luxembourg and Imports(as % of merchandise exports) in Tunisia?
Keep it short and to the point. -3.42. In the year 2010, what is the difference between the Imports(as % of merchandise exports) of Cambodia and Imports(as % of merchandise exports) of Kazakhstan?
Give a very brief answer. -2.68. In the year 2010, what is the difference between the Imports(as % of merchandise exports) in Cambodia and Imports(as % of merchandise exports) in Luxembourg?
Offer a very short reply. -2.68. In the year 2010, what is the difference between the Imports(as % of merchandise exports) in Cambodia and Imports(as % of merchandise exports) in Tunisia?
Give a very brief answer. -5.29. In the year 2010, what is the difference between the Imports(as % of merchandise exports) in Kazakhstan and Imports(as % of merchandise exports) in Luxembourg?
Offer a very short reply. 0. In the year 2010, what is the difference between the Imports(as % of merchandise exports) of Kazakhstan and Imports(as % of merchandise exports) of Tunisia?
Keep it short and to the point. -2.61. In the year 2010, what is the difference between the Imports(as % of merchandise exports) of Luxembourg and Imports(as % of merchandise exports) of Tunisia?
Ensure brevity in your answer.  -2.61. In the year 2011, what is the difference between the Imports(as % of merchandise exports) of Cambodia and Imports(as % of merchandise exports) of Kazakhstan?
Give a very brief answer. 0.95. In the year 2011, what is the difference between the Imports(as % of merchandise exports) of Cambodia and Imports(as % of merchandise exports) of Luxembourg?
Your answer should be compact. 2.82. In the year 2011, what is the difference between the Imports(as % of merchandise exports) of Cambodia and Imports(as % of merchandise exports) of Tunisia?
Offer a terse response. -0.96. In the year 2011, what is the difference between the Imports(as % of merchandise exports) of Kazakhstan and Imports(as % of merchandise exports) of Luxembourg?
Your answer should be compact. 1.87. In the year 2011, what is the difference between the Imports(as % of merchandise exports) in Kazakhstan and Imports(as % of merchandise exports) in Tunisia?
Your response must be concise. -1.91. In the year 2011, what is the difference between the Imports(as % of merchandise exports) of Luxembourg and Imports(as % of merchandise exports) of Tunisia?
Provide a short and direct response. -3.78. What is the ratio of the Imports(as % of merchandise exports) of Kazakhstan in 2005 to that in 2006?
Provide a succinct answer. 0.92. What is the ratio of the Imports(as % of merchandise exports) of Luxembourg in 2005 to that in 2006?
Provide a short and direct response. 0.96. What is the ratio of the Imports(as % of merchandise exports) of Tunisia in 2005 to that in 2006?
Your answer should be compact. 0.92. What is the ratio of the Imports(as % of merchandise exports) in Cambodia in 2005 to that in 2007?
Keep it short and to the point. 0.88. What is the ratio of the Imports(as % of merchandise exports) in Kazakhstan in 2005 to that in 2007?
Offer a terse response. 1.07. What is the ratio of the Imports(as % of merchandise exports) in Luxembourg in 2005 to that in 2007?
Your response must be concise. 1.04. What is the ratio of the Imports(as % of merchandise exports) in Tunisia in 2005 to that in 2007?
Provide a short and direct response. 1.07. What is the ratio of the Imports(as % of merchandise exports) in Cambodia in 2005 to that in 2008?
Give a very brief answer. 0.96. What is the ratio of the Imports(as % of merchandise exports) of Kazakhstan in 2005 to that in 2008?
Your response must be concise. 0.83. What is the ratio of the Imports(as % of merchandise exports) in Luxembourg in 2005 to that in 2008?
Provide a short and direct response. 0.83. What is the ratio of the Imports(as % of merchandise exports) in Tunisia in 2005 to that in 2008?
Offer a very short reply. 0.81. What is the ratio of the Imports(as % of merchandise exports) in Cambodia in 2005 to that in 2009?
Keep it short and to the point. 0.74. What is the ratio of the Imports(as % of merchandise exports) in Kazakhstan in 2005 to that in 2009?
Your answer should be compact. 1.19. What is the ratio of the Imports(as % of merchandise exports) of Luxembourg in 2005 to that in 2009?
Make the answer very short. 1.15. What is the ratio of the Imports(as % of merchandise exports) in Tunisia in 2005 to that in 2009?
Offer a terse response. 1.2. What is the ratio of the Imports(as % of merchandise exports) of Kazakhstan in 2005 to that in 2010?
Provide a short and direct response. 1.2. What is the ratio of the Imports(as % of merchandise exports) of Luxembourg in 2005 to that in 2010?
Your response must be concise. 0.93. What is the ratio of the Imports(as % of merchandise exports) of Tunisia in 2005 to that in 2010?
Your response must be concise. 1.09. What is the ratio of the Imports(as % of merchandise exports) in Cambodia in 2005 to that in 2011?
Keep it short and to the point. 0.53. What is the ratio of the Imports(as % of merchandise exports) of Kazakhstan in 2005 to that in 2011?
Ensure brevity in your answer.  0.93. What is the ratio of the Imports(as % of merchandise exports) of Luxembourg in 2005 to that in 2011?
Offer a very short reply. 0.84. What is the ratio of the Imports(as % of merchandise exports) of Tunisia in 2005 to that in 2011?
Offer a very short reply. 0.93. What is the ratio of the Imports(as % of merchandise exports) of Cambodia in 2006 to that in 2007?
Provide a short and direct response. 0.95. What is the ratio of the Imports(as % of merchandise exports) of Kazakhstan in 2006 to that in 2007?
Your answer should be compact. 1.16. What is the ratio of the Imports(as % of merchandise exports) of Luxembourg in 2006 to that in 2007?
Your response must be concise. 1.09. What is the ratio of the Imports(as % of merchandise exports) of Tunisia in 2006 to that in 2007?
Ensure brevity in your answer.  1.15. What is the ratio of the Imports(as % of merchandise exports) in Cambodia in 2006 to that in 2008?
Ensure brevity in your answer.  1.03. What is the ratio of the Imports(as % of merchandise exports) in Kazakhstan in 2006 to that in 2008?
Keep it short and to the point. 0.9. What is the ratio of the Imports(as % of merchandise exports) of Luxembourg in 2006 to that in 2008?
Your response must be concise. 0.86. What is the ratio of the Imports(as % of merchandise exports) of Tunisia in 2006 to that in 2008?
Keep it short and to the point. 0.88. What is the ratio of the Imports(as % of merchandise exports) of Cambodia in 2006 to that in 2009?
Give a very brief answer. 0.8. What is the ratio of the Imports(as % of merchandise exports) in Kazakhstan in 2006 to that in 2009?
Your response must be concise. 1.29. What is the ratio of the Imports(as % of merchandise exports) of Luxembourg in 2006 to that in 2009?
Provide a succinct answer. 1.2. What is the ratio of the Imports(as % of merchandise exports) of Tunisia in 2006 to that in 2009?
Offer a very short reply. 1.29. What is the ratio of the Imports(as % of merchandise exports) in Kazakhstan in 2006 to that in 2010?
Make the answer very short. 1.3. What is the ratio of the Imports(as % of merchandise exports) of Luxembourg in 2006 to that in 2010?
Offer a very short reply. 0.96. What is the ratio of the Imports(as % of merchandise exports) in Tunisia in 2006 to that in 2010?
Offer a terse response. 1.18. What is the ratio of the Imports(as % of merchandise exports) in Cambodia in 2006 to that in 2011?
Offer a very short reply. 0.57. What is the ratio of the Imports(as % of merchandise exports) in Luxembourg in 2006 to that in 2011?
Your response must be concise. 0.87. What is the ratio of the Imports(as % of merchandise exports) of Tunisia in 2006 to that in 2011?
Provide a short and direct response. 1. What is the ratio of the Imports(as % of merchandise exports) of Cambodia in 2007 to that in 2008?
Your response must be concise. 1.09. What is the ratio of the Imports(as % of merchandise exports) of Kazakhstan in 2007 to that in 2008?
Offer a very short reply. 0.78. What is the ratio of the Imports(as % of merchandise exports) in Luxembourg in 2007 to that in 2008?
Give a very brief answer. 0.79. What is the ratio of the Imports(as % of merchandise exports) of Tunisia in 2007 to that in 2008?
Your response must be concise. 0.76. What is the ratio of the Imports(as % of merchandise exports) of Cambodia in 2007 to that in 2009?
Your response must be concise. 0.84. What is the ratio of the Imports(as % of merchandise exports) in Kazakhstan in 2007 to that in 2009?
Ensure brevity in your answer.  1.11. What is the ratio of the Imports(as % of merchandise exports) of Luxembourg in 2007 to that in 2009?
Your response must be concise. 1.1. What is the ratio of the Imports(as % of merchandise exports) in Tunisia in 2007 to that in 2009?
Ensure brevity in your answer.  1.12. What is the ratio of the Imports(as % of merchandise exports) in Cambodia in 2007 to that in 2010?
Your answer should be compact. 1.14. What is the ratio of the Imports(as % of merchandise exports) in Kazakhstan in 2007 to that in 2010?
Your answer should be very brief. 1.12. What is the ratio of the Imports(as % of merchandise exports) in Luxembourg in 2007 to that in 2010?
Your response must be concise. 0.89. What is the ratio of the Imports(as % of merchandise exports) in Tunisia in 2007 to that in 2010?
Your answer should be compact. 1.02. What is the ratio of the Imports(as % of merchandise exports) of Cambodia in 2007 to that in 2011?
Provide a short and direct response. 0.6. What is the ratio of the Imports(as % of merchandise exports) of Kazakhstan in 2007 to that in 2011?
Your response must be concise. 0.87. What is the ratio of the Imports(as % of merchandise exports) of Luxembourg in 2007 to that in 2011?
Offer a very short reply. 0.8. What is the ratio of the Imports(as % of merchandise exports) of Tunisia in 2007 to that in 2011?
Provide a succinct answer. 0.87. What is the ratio of the Imports(as % of merchandise exports) in Cambodia in 2008 to that in 2009?
Offer a very short reply. 0.77. What is the ratio of the Imports(as % of merchandise exports) in Kazakhstan in 2008 to that in 2009?
Keep it short and to the point. 1.44. What is the ratio of the Imports(as % of merchandise exports) of Luxembourg in 2008 to that in 2009?
Offer a terse response. 1.39. What is the ratio of the Imports(as % of merchandise exports) in Tunisia in 2008 to that in 2009?
Give a very brief answer. 1.47. What is the ratio of the Imports(as % of merchandise exports) of Cambodia in 2008 to that in 2010?
Provide a succinct answer. 1.04. What is the ratio of the Imports(as % of merchandise exports) of Kazakhstan in 2008 to that in 2010?
Your answer should be very brief. 1.44. What is the ratio of the Imports(as % of merchandise exports) of Luxembourg in 2008 to that in 2010?
Offer a very short reply. 1.12. What is the ratio of the Imports(as % of merchandise exports) of Tunisia in 2008 to that in 2010?
Ensure brevity in your answer.  1.34. What is the ratio of the Imports(as % of merchandise exports) in Cambodia in 2008 to that in 2011?
Give a very brief answer. 0.55. What is the ratio of the Imports(as % of merchandise exports) of Kazakhstan in 2008 to that in 2011?
Provide a short and direct response. 1.12. What is the ratio of the Imports(as % of merchandise exports) in Luxembourg in 2008 to that in 2011?
Your answer should be compact. 1.01. What is the ratio of the Imports(as % of merchandise exports) of Tunisia in 2008 to that in 2011?
Your answer should be compact. 1.14. What is the ratio of the Imports(as % of merchandise exports) of Cambodia in 2009 to that in 2010?
Make the answer very short. 1.36. What is the ratio of the Imports(as % of merchandise exports) in Kazakhstan in 2009 to that in 2010?
Offer a very short reply. 1.01. What is the ratio of the Imports(as % of merchandise exports) of Luxembourg in 2009 to that in 2010?
Make the answer very short. 0.81. What is the ratio of the Imports(as % of merchandise exports) of Tunisia in 2009 to that in 2010?
Offer a terse response. 0.91. What is the ratio of the Imports(as % of merchandise exports) of Cambodia in 2009 to that in 2011?
Offer a very short reply. 0.72. What is the ratio of the Imports(as % of merchandise exports) of Kazakhstan in 2009 to that in 2011?
Your answer should be compact. 0.78. What is the ratio of the Imports(as % of merchandise exports) in Luxembourg in 2009 to that in 2011?
Your response must be concise. 0.73. What is the ratio of the Imports(as % of merchandise exports) of Tunisia in 2009 to that in 2011?
Your response must be concise. 0.77. What is the ratio of the Imports(as % of merchandise exports) in Cambodia in 2010 to that in 2011?
Your answer should be compact. 0.53. What is the ratio of the Imports(as % of merchandise exports) in Kazakhstan in 2010 to that in 2011?
Your answer should be very brief. 0.77. What is the ratio of the Imports(as % of merchandise exports) of Luxembourg in 2010 to that in 2011?
Keep it short and to the point. 0.9. What is the ratio of the Imports(as % of merchandise exports) in Tunisia in 2010 to that in 2011?
Your answer should be compact. 0.85. What is the difference between the highest and the second highest Imports(as % of merchandise exports) in Cambodia?
Provide a succinct answer. 3.95. What is the difference between the highest and the second highest Imports(as % of merchandise exports) in Kazakhstan?
Your answer should be compact. 1.46. What is the difference between the highest and the second highest Imports(as % of merchandise exports) of Luxembourg?
Make the answer very short. 0.15. What is the difference between the highest and the second highest Imports(as % of merchandise exports) of Tunisia?
Provide a succinct answer. 2.06. What is the difference between the highest and the lowest Imports(as % of merchandise exports) in Cambodia?
Provide a succinct answer. 6.56. What is the difference between the highest and the lowest Imports(as % of merchandise exports) in Kazakhstan?
Offer a very short reply. 4.44. What is the difference between the highest and the lowest Imports(as % of merchandise exports) of Luxembourg?
Give a very brief answer. 3.16. What is the difference between the highest and the lowest Imports(as % of merchandise exports) in Tunisia?
Make the answer very short. 5.43. 